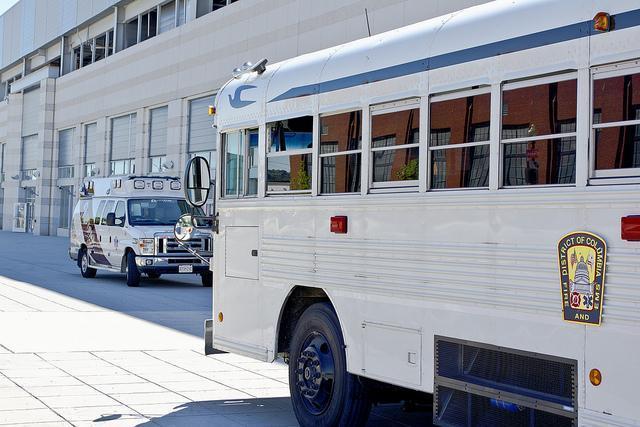How many cats with spots do you see?
Give a very brief answer. 0. 